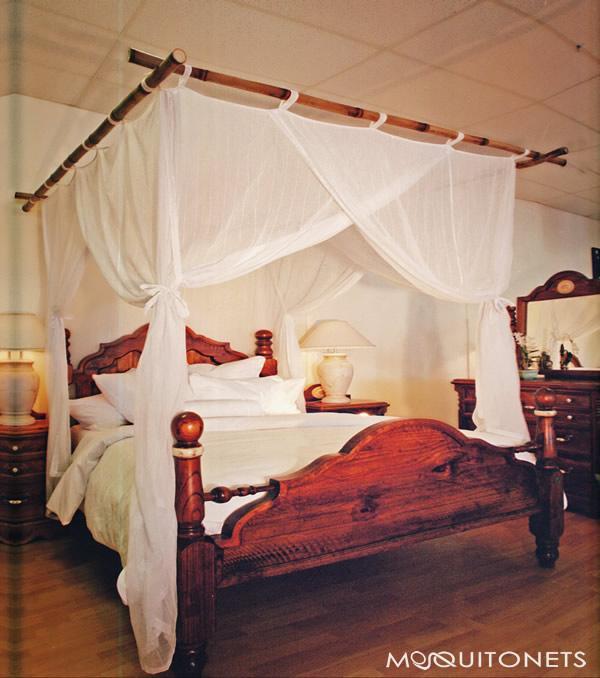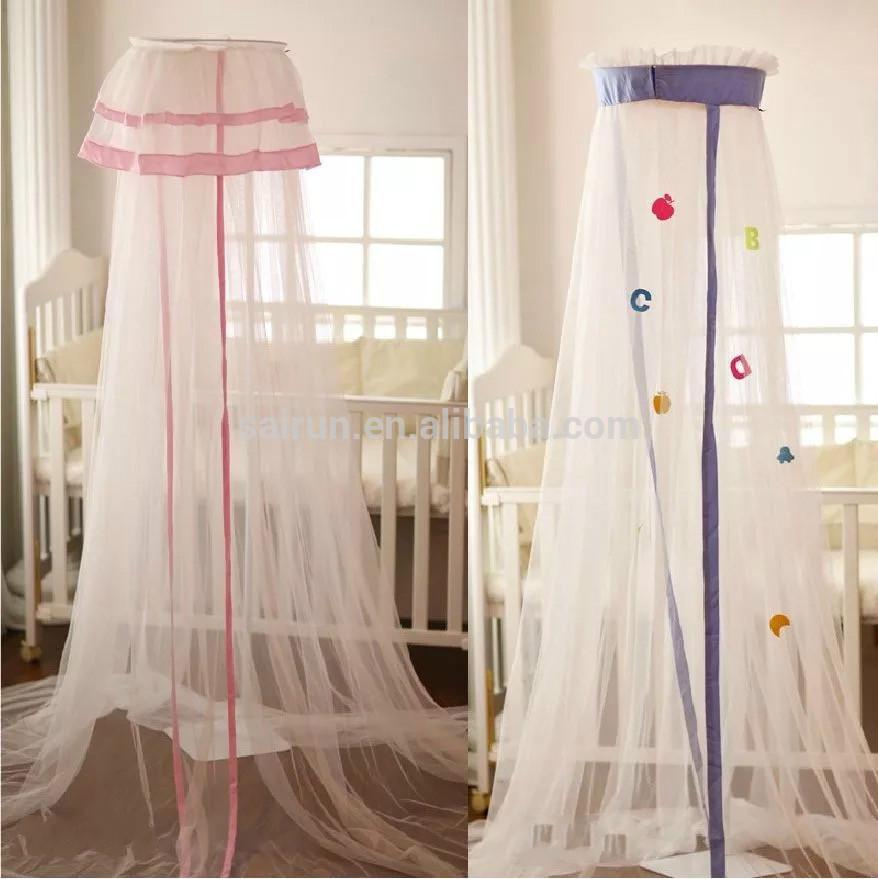The first image is the image on the left, the second image is the image on the right. Assess this claim about the two images: "The bed in the image on the right is covered by a curved tent.". Correct or not? Answer yes or no. No. 